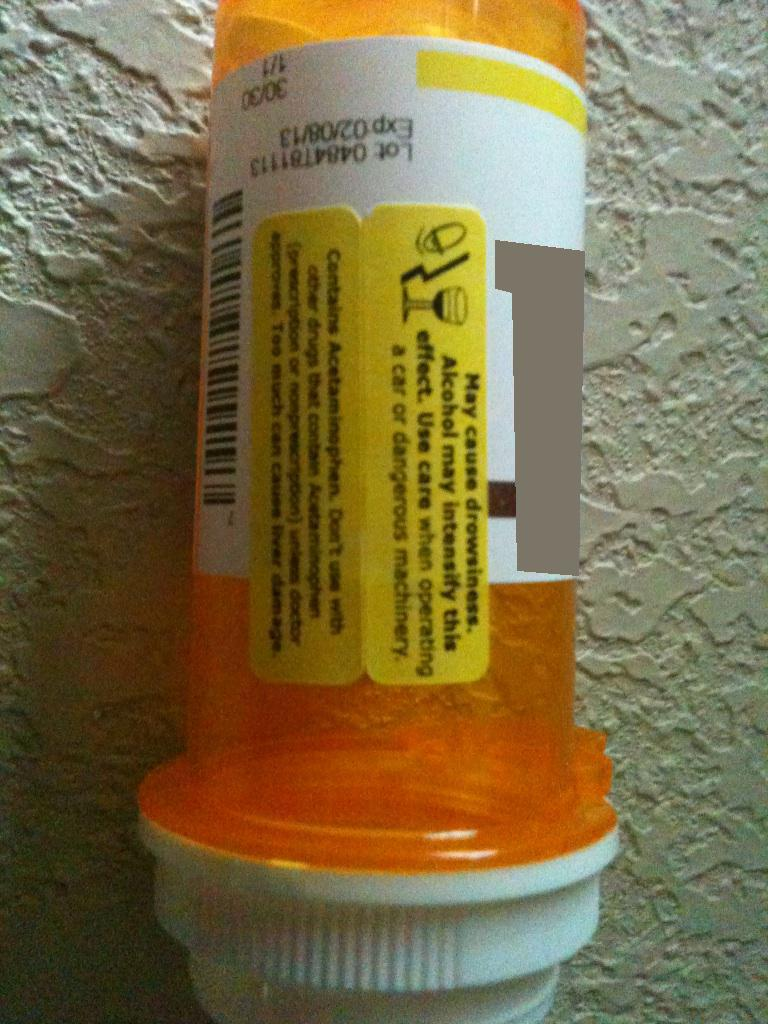A concise question about the label. Does the label advise against drinking alcohol while using this medication?  A short response Yes, the label advises against consuming alcohol as it may intensify the drowsiness effect of the medication. 